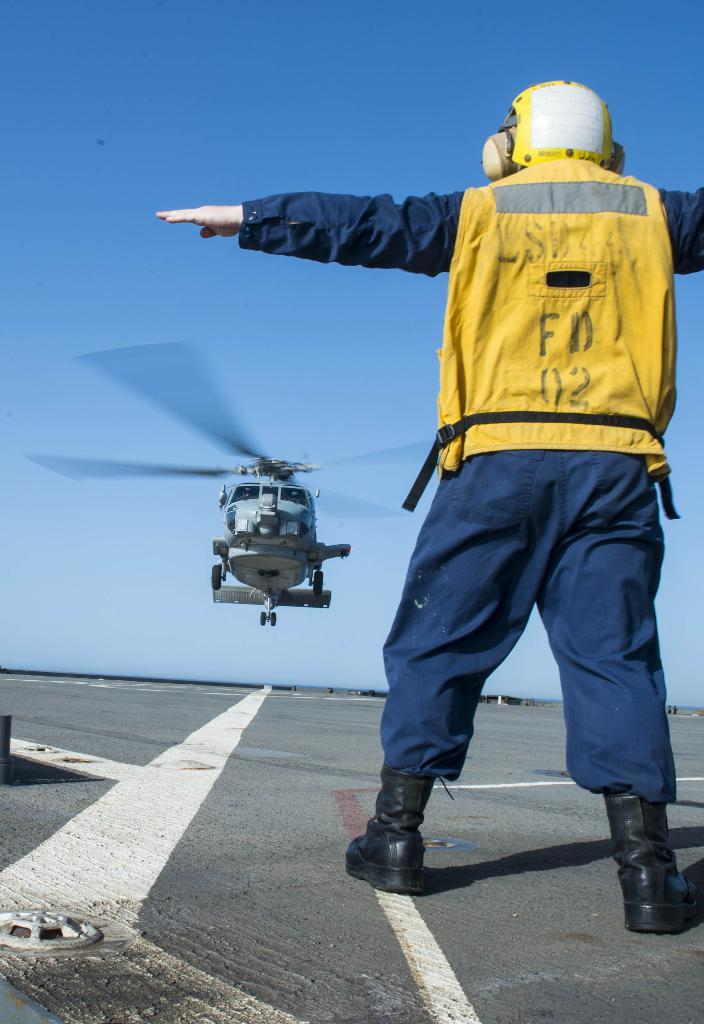<image>
Present a compact description of the photo's key features. A flight director in a yellow FD 02 vest directs a helicopter. 